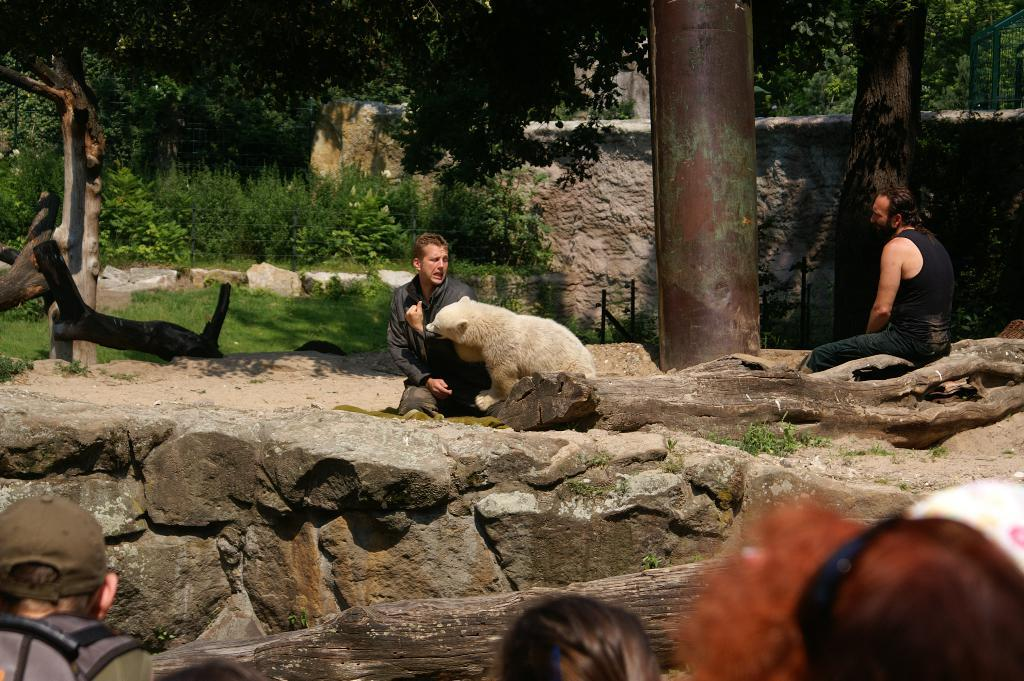What type of animal is in the image? There is an animal in the image, but the specific type cannot be determined from the provided facts. Who or what else is present in the image? There are people and a rock visible in the image. What can be seen in the background of the image? In the background of the image, there is grass, plants, trees, and a wall. What type of cast can be seen on the animal's leg in the image? There is no cast visible on any animal's leg in the image. What sound does the animal make in the image? The provided facts do not mention any sounds or vocalizations made by the animal in the image. 